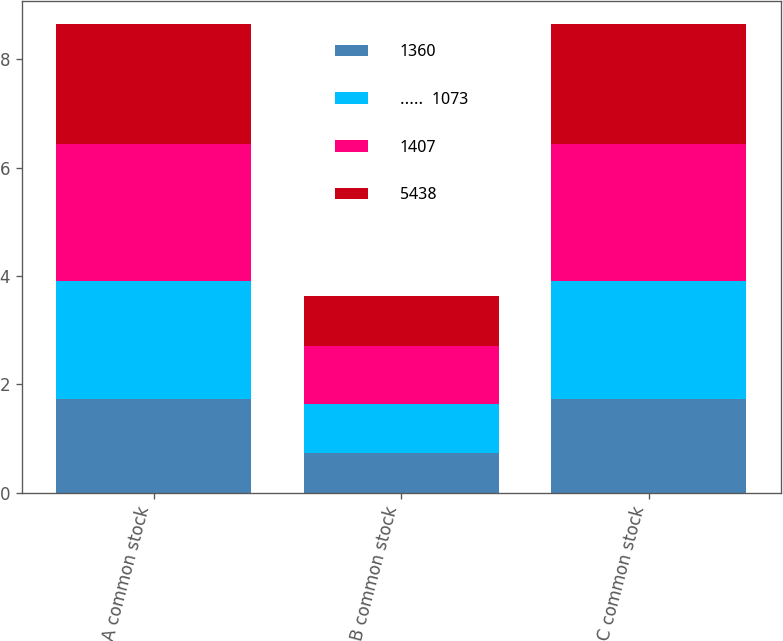<chart> <loc_0><loc_0><loc_500><loc_500><stacked_bar_chart><ecel><fcel>Class A common stock<fcel>Class B common stock<fcel>Class C common stock<nl><fcel>1360<fcel>1.73<fcel>0.73<fcel>1.73<nl><fcel>.....  1073<fcel>2.17<fcel>0.91<fcel>2.17<nl><fcel>1407<fcel>2.53<fcel>1.06<fcel>2.53<nl><fcel>5438<fcel>2.21<fcel>0.93<fcel>2.21<nl></chart> 